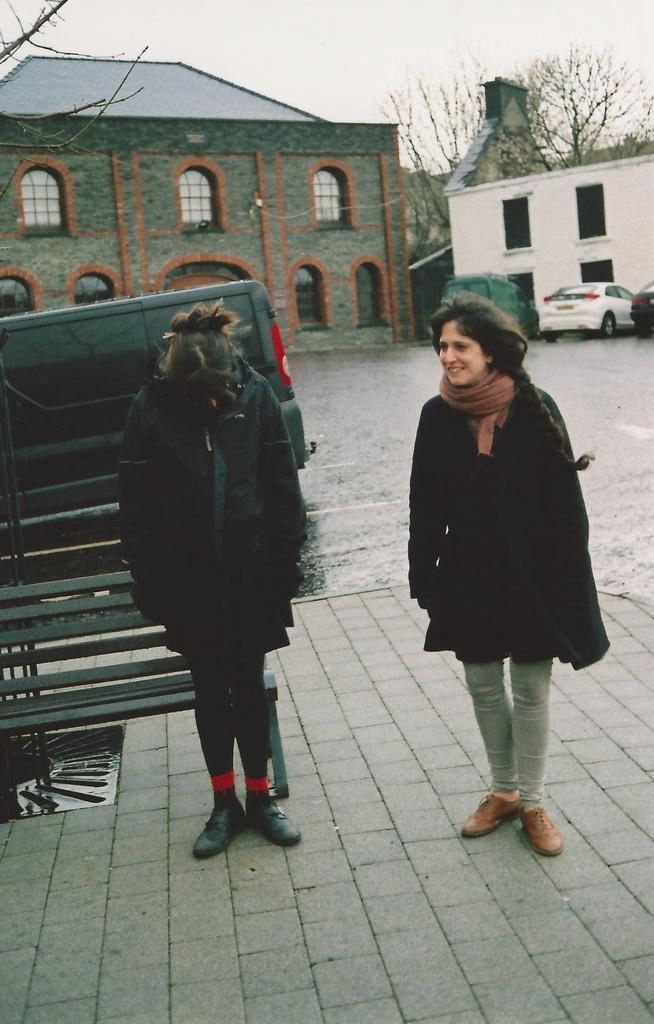How many people are in the image? There are two persons standing in the image. What is the object they are standing near? There is a bench in the image. What type of natural elements can be seen in the image? There are trees in the image. What type of man-made structures are visible in the image? There are buildings in the image. What type of transportation can be seen in the image? There are vehicles in the image. What is visible in the background of the image? The sky is visible in the background of the image. What type of scent can be smelled coming from the chickens in the image? There are no chickens present in the image, so it is not possible to determine any scent. 